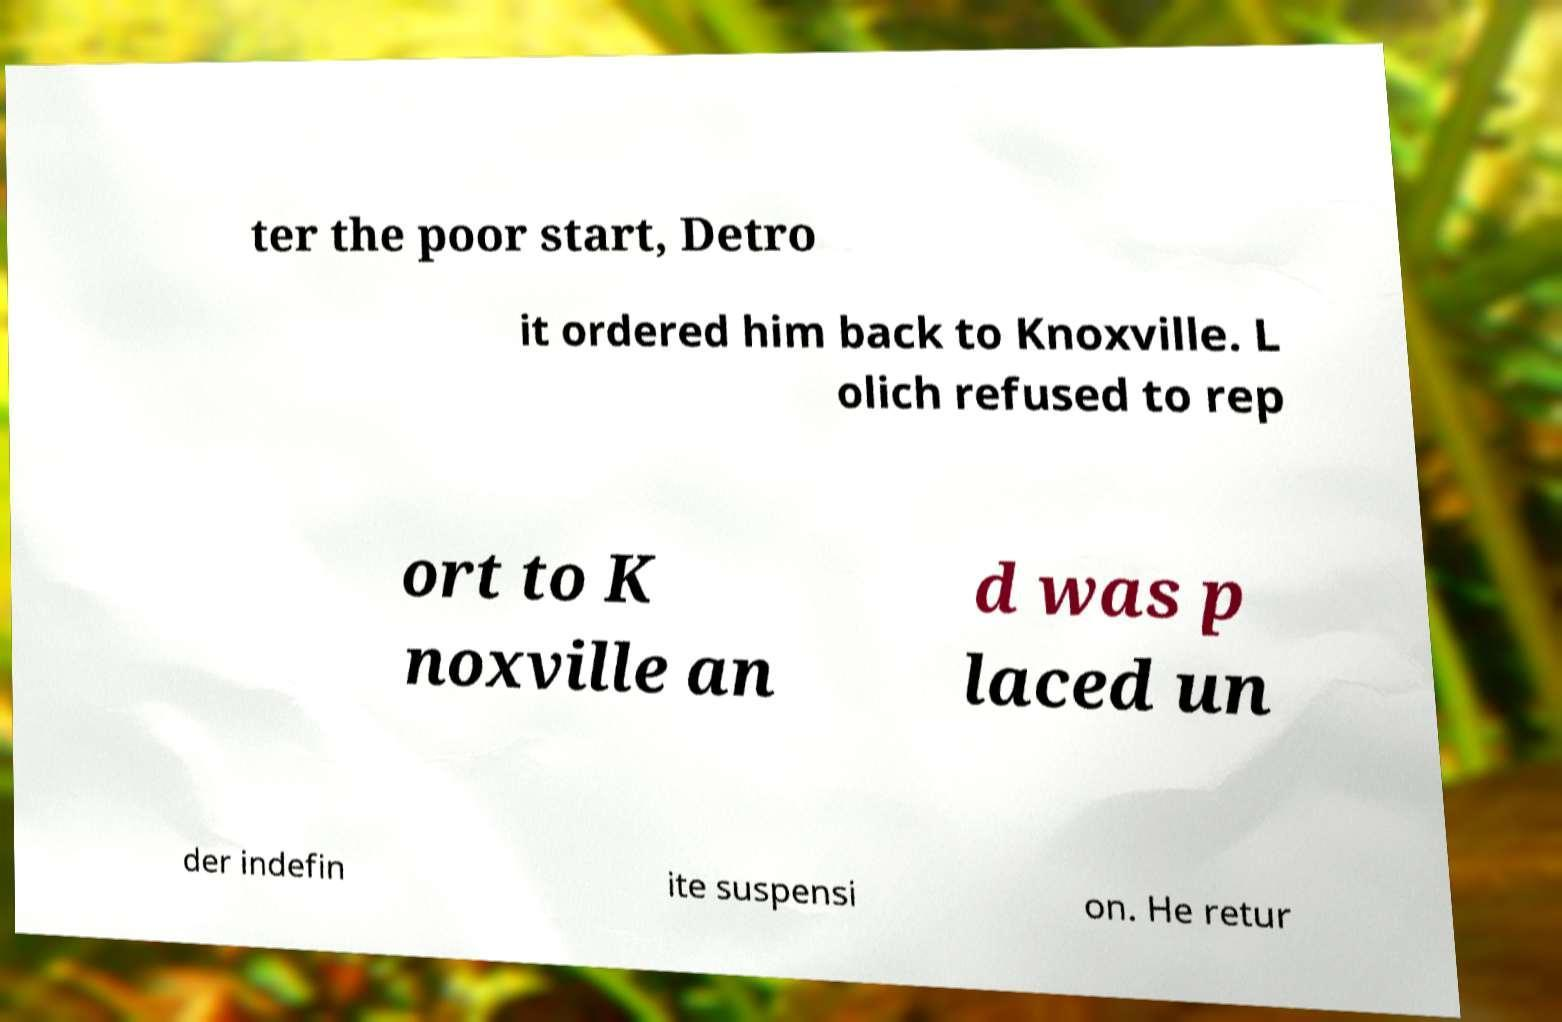Please identify and transcribe the text found in this image. ter the poor start, Detro it ordered him back to Knoxville. L olich refused to rep ort to K noxville an d was p laced un der indefin ite suspensi on. He retur 